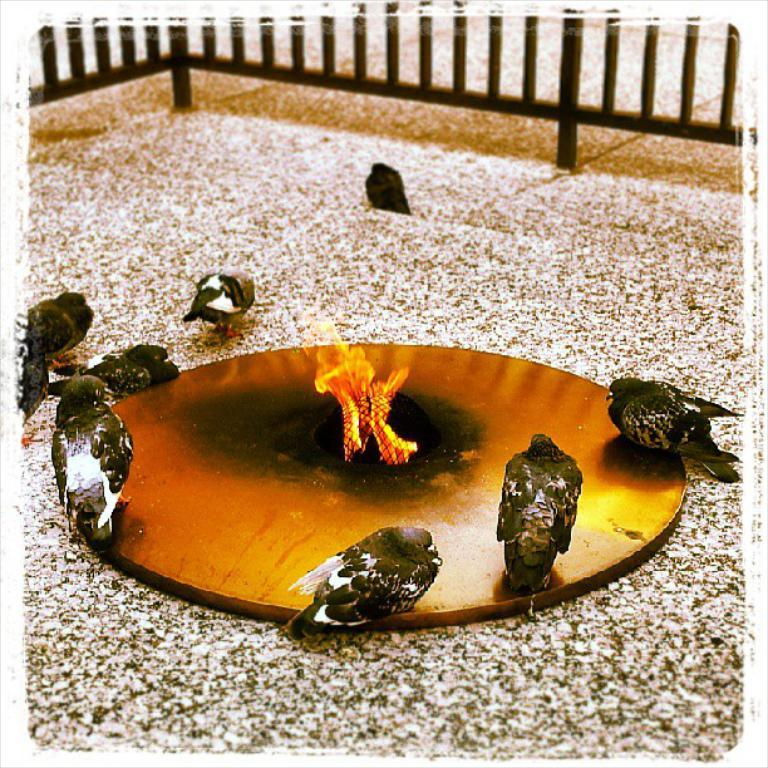What animals are present on the object in the image? There are birds on an object in the image. What can be seen in the middle of the object? There is a flame in the middle of the object. What type of barrier is visible at the top of the image? There is a fence at the top of the image. Can you tell me how many cats are hanging from the hook in the image? There is no hook or cat present in the image. What type of vacation is being advertised in the image? There is no advertisement or mention of a vacation in the image. 